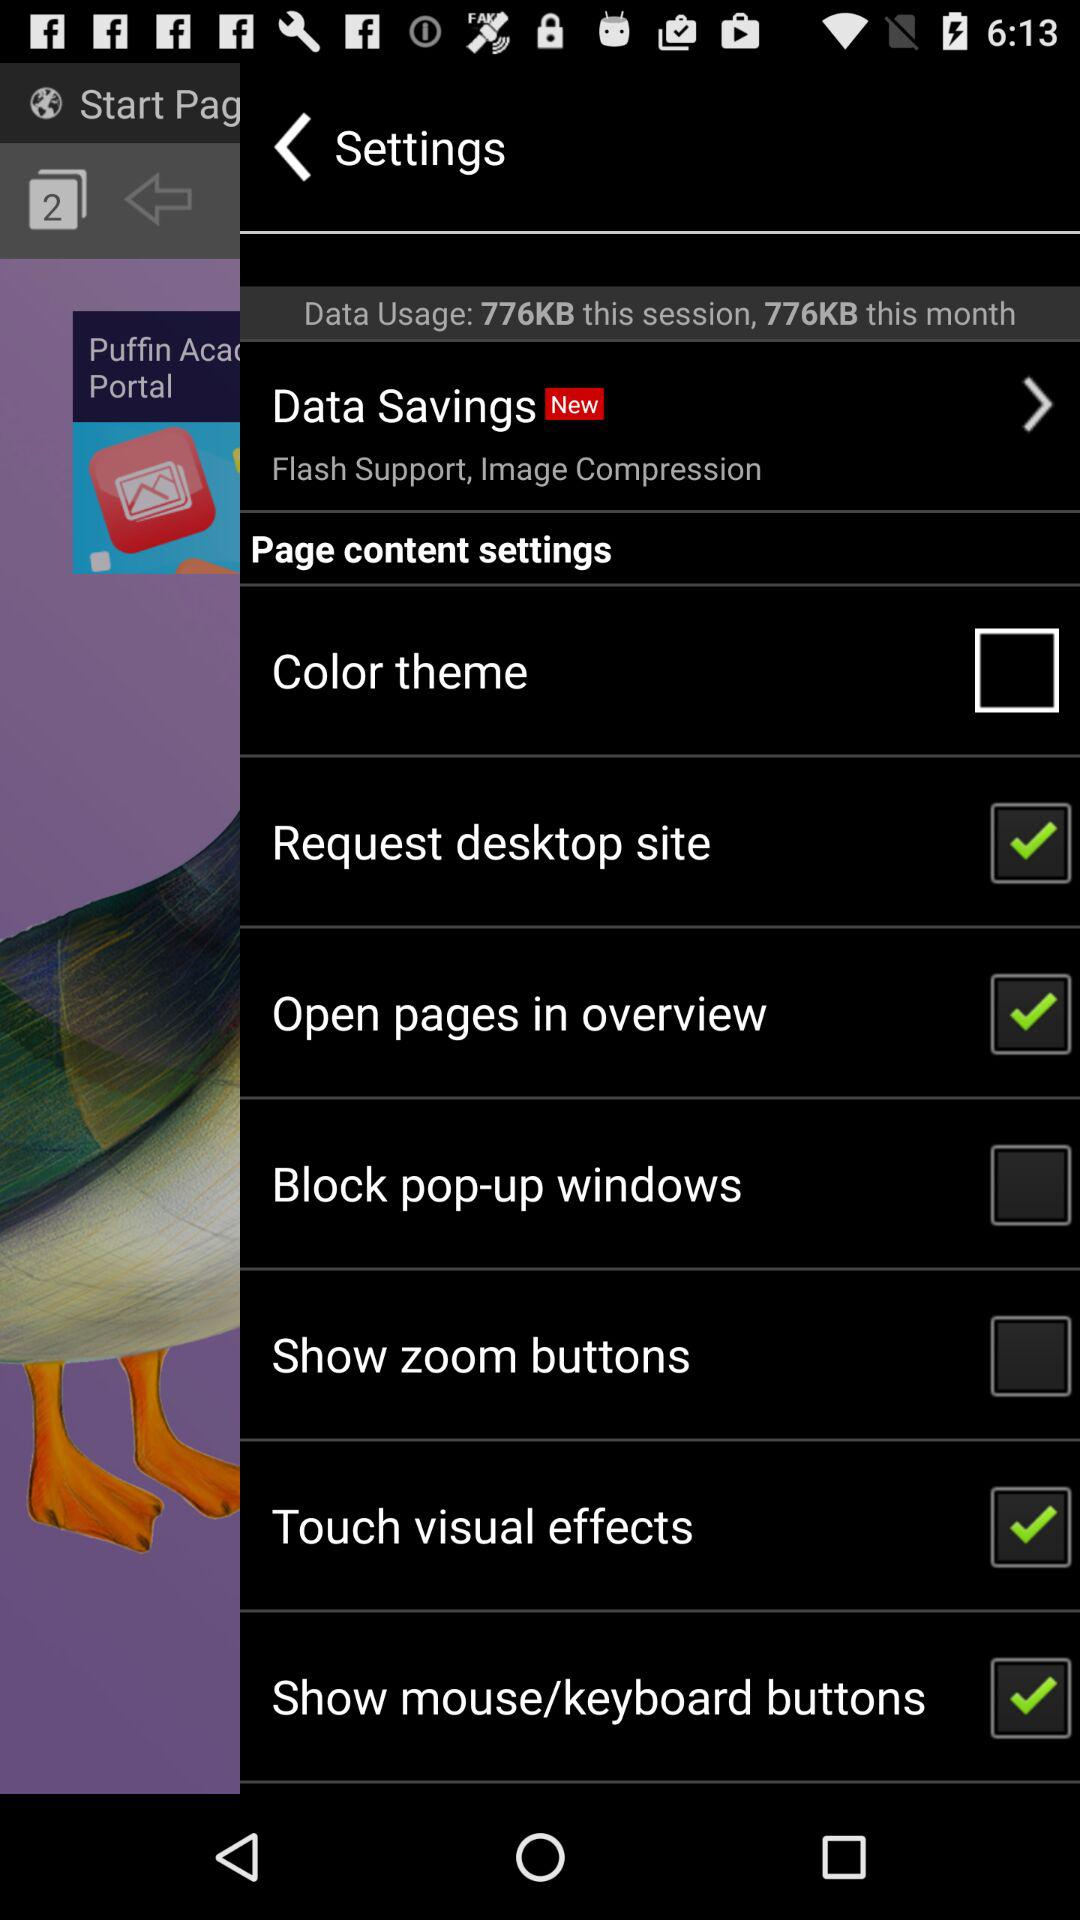What is the current status of the "Request desktop site" setting? The status is "on". 